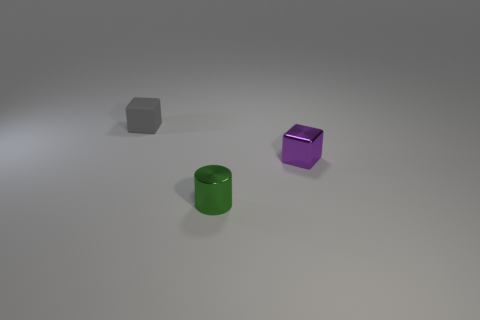Add 1 yellow things. How many objects exist? 4 Subtract 1 cubes. How many cubes are left? 1 Subtract all purple blocks. How many blocks are left? 1 Subtract all cylinders. How many objects are left? 2 Add 3 tiny things. How many tiny things are left? 6 Add 3 purple balls. How many purple balls exist? 3 Subtract 0 green blocks. How many objects are left? 3 Subtract all red cubes. Subtract all gray cylinders. How many cubes are left? 2 Subtract all brown cylinders. How many purple cubes are left? 1 Subtract all purple spheres. Subtract all matte things. How many objects are left? 2 